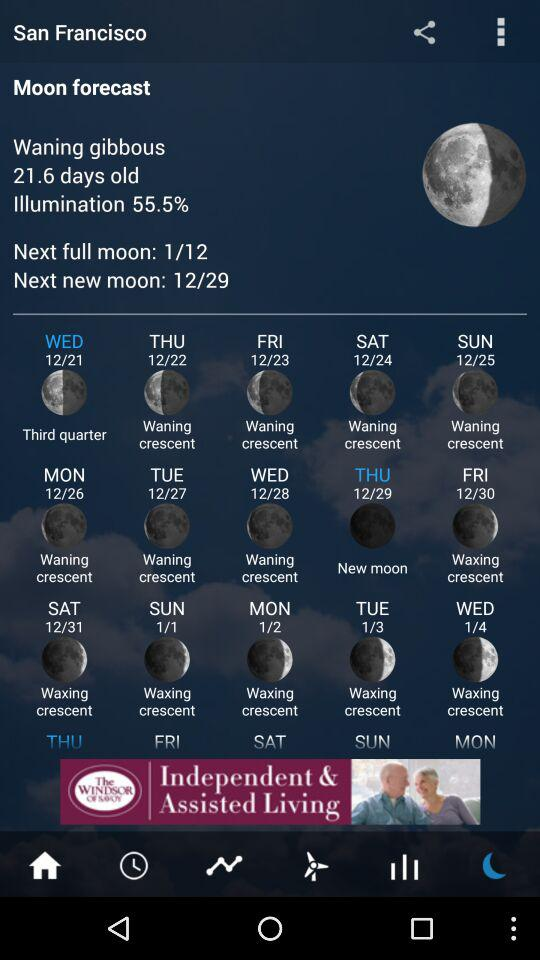How does the moon phase change from 12/24 to 1/4? From December 24th to January 4th, the moon's visible portion gradually decreases, then becomes entirely dark during the new moon before progressively increasing in visibility. This transformation involves moving from a waning crescent to a new moon and finally to a waxing crescent, showcasing the dynamic lunar cycle.  Why is the illumination percentage important in understanding the moon phases? The illumination percentage reflects the amount of the moon's visible disk lit by the sun. It provides a quantitative measure of the moon's phase, with 0% being a new moon and 100% being a full moon. Changes in this percentage help predict the moon's appearance and its impact on nighttime visibility and tides. 